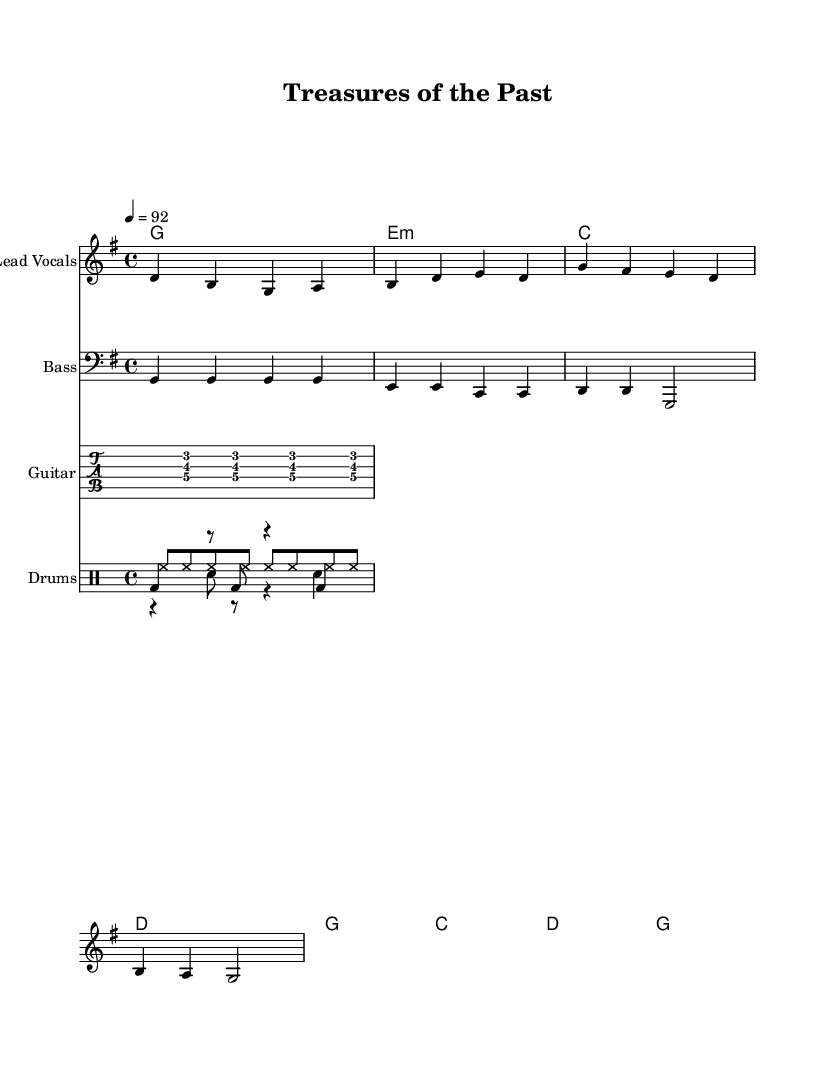What is the key signature of this music? The key signature is G major, which has one sharp (F#) indicated at the beginning of the staff.
Answer: G major What is the time signature of this music? The time signature shown is 4/4, meaning there are four beats in each measure and the quarter note gets one beat.
Answer: 4/4 What is the tempo marking in this piece? The tempo marking is indicated as quarter note equals 92, meaning that each quarter note should be played at a speed of 92 beats per minute.
Answer: 92 How many measures are in the verse? The verse consists of 4 measures as indicated by the distinct grouping of notes and corresponding chord changes.
Answer: 4 What instruments are included in this score? The score includes Lead Vocals, Bass, Guitar, and Drums, as indicated by the separate staff and tab staff for each instrument.
Answer: Lead Vocals, Bass, Guitar, and Drums Explain the chord progression in the chorus. The chord progression in the chorus consists of G major, C major, D major, and back to G major, shown in the chord mode section and corresponding to the melody.
Answer: G, C, D, G What thematic element do the lyrics represent? The lyrics "Ancient maps and compasses guide my way" suggest themes of exploration and adventure, resonant with reggae's storytelling tradition.
Answer: Exploration and adventure 